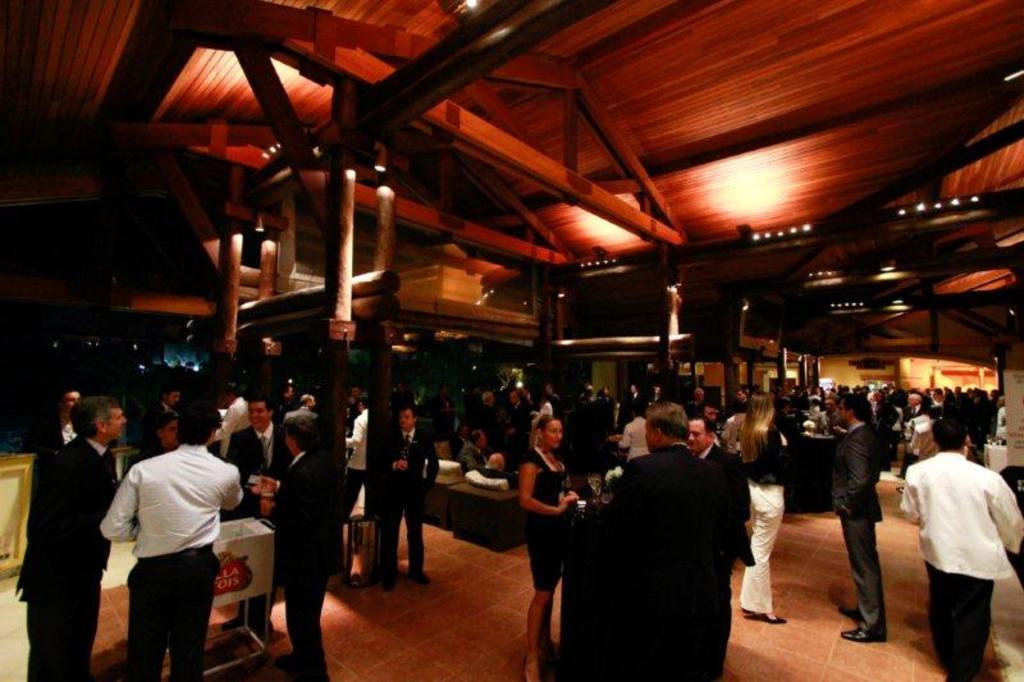In one or two sentences, can you explain what this image depicts? In this image we can see many people. There are wooden pillars. On the ceiling there are lights. And the ceiling is wooden. And there are few other items. 